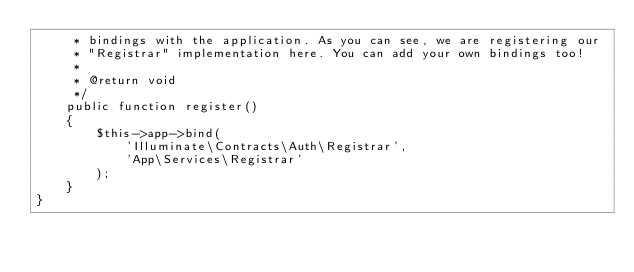Convert code to text. <code><loc_0><loc_0><loc_500><loc_500><_PHP_>     * bindings with the application. As you can see, we are registering our
     * "Registrar" implementation here. You can add your own bindings too!
     *
     * @return void
     */
    public function register()
    {
        $this->app->bind(
            'Illuminate\Contracts\Auth\Registrar',
            'App\Services\Registrar'
        );
    }
}
</code> 